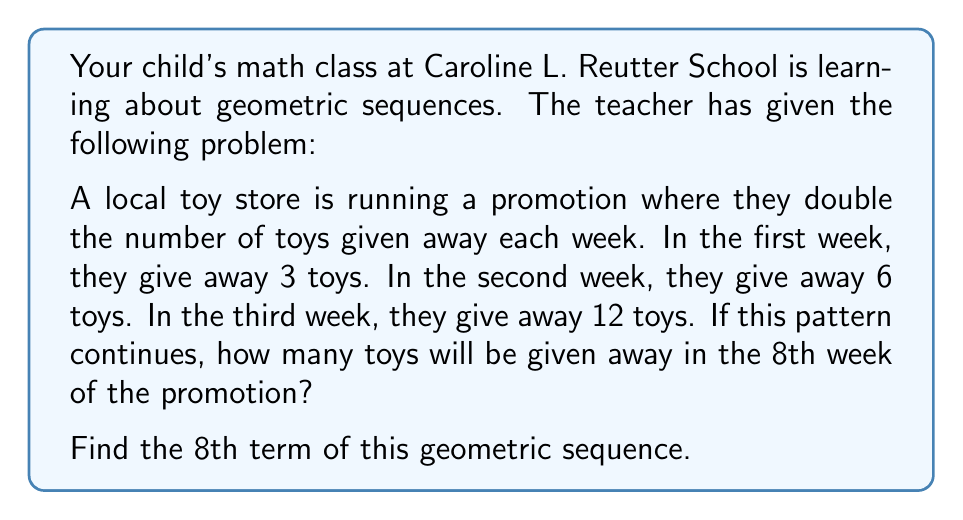Solve this math problem. Let's approach this step-by-step:

1) First, we need to identify the components of the geometric sequence:
   - $a_1 = 3$ (first term)
   - $r = 2$ (common ratio, as each term is double the previous)

2) The general formula for the nth term of a geometric sequence is:

   $a_n = a_1 \cdot r^{n-1}$

   Where:
   $a_n$ is the nth term
   $a_1$ is the first term
   $r$ is the common ratio
   $n$ is the position of the term we're looking for

3) We're looking for the 8th term, so $n = 8$

4) Let's substitute these values into our formula:

   $a_8 = 3 \cdot 2^{8-1}$

5) Simplify:
   $a_8 = 3 \cdot 2^7$

6) Calculate:
   $a_8 = 3 \cdot 128 = 384$

Therefore, in the 8th week of the promotion, 384 toys will be given away.
Answer: $a_8 = 384$ toys 